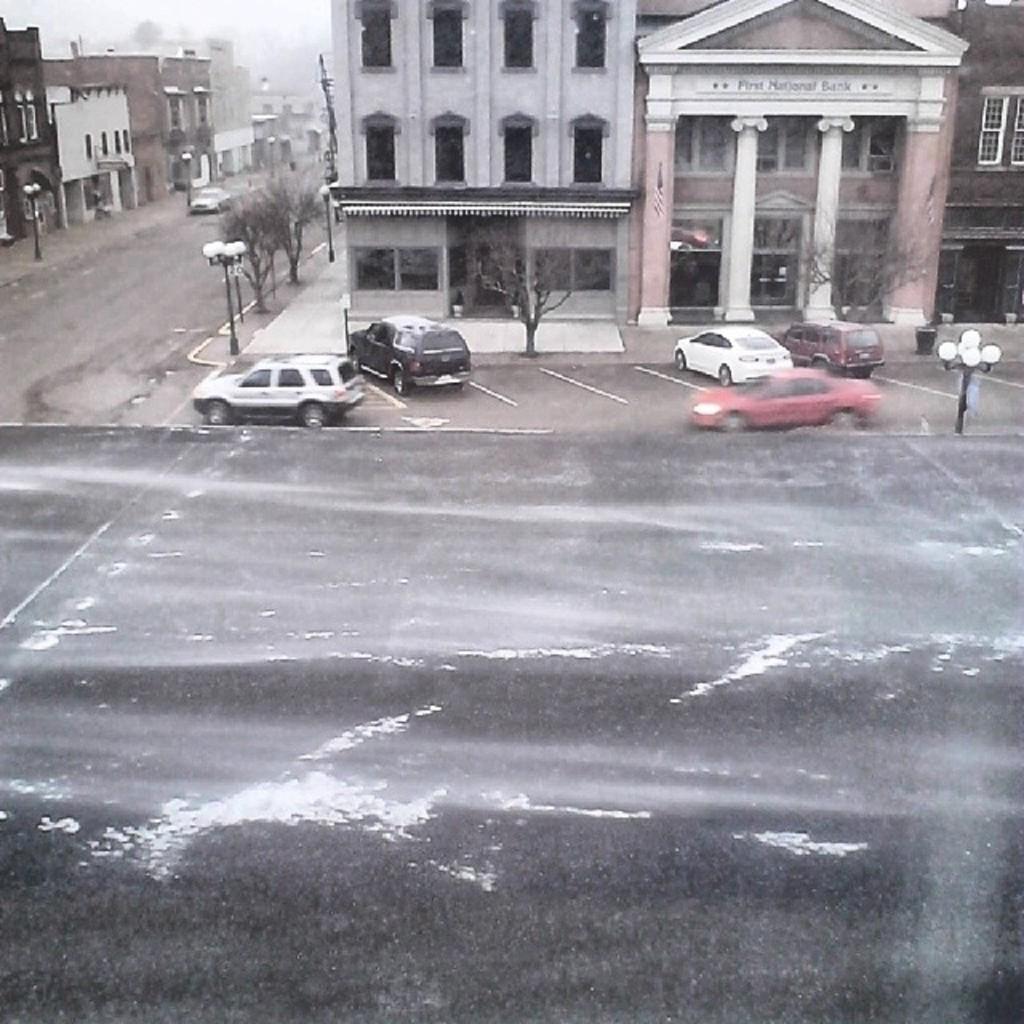Please provide a concise description of this image. In this picture we can see the outside view of a city. These are the vehicles on the road. And this is the road. There are some buildings. These are the trees. And this is the sky. 